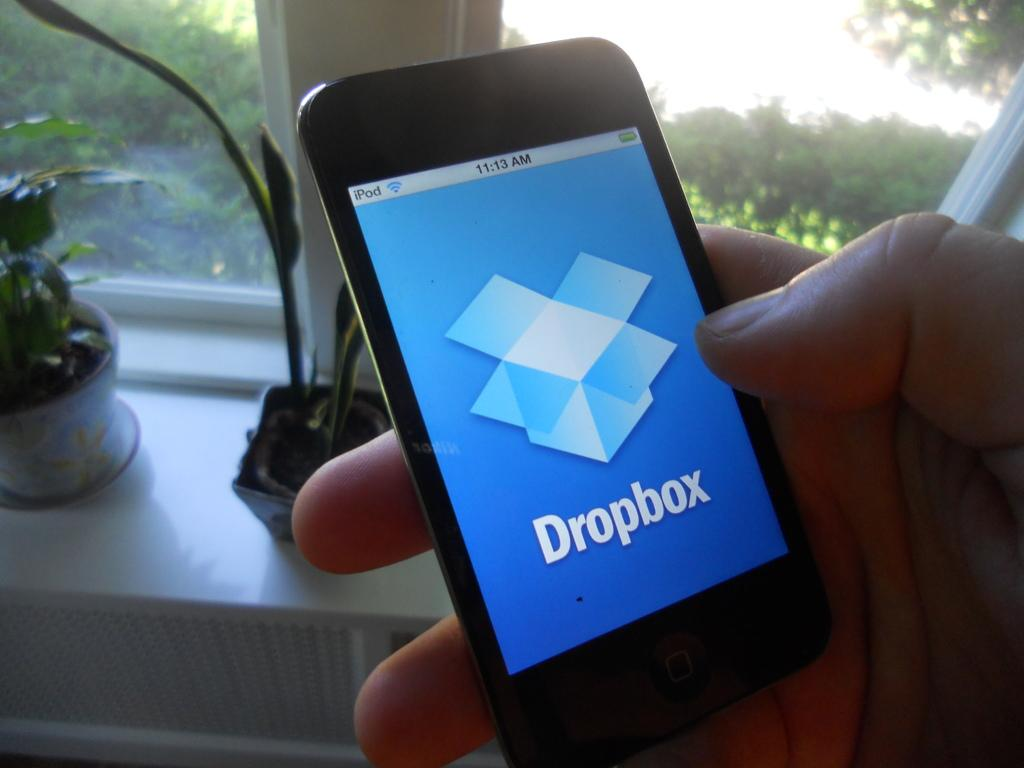What is the person in the image holding? The person is holding a mobile in the image. What part of the person is visible in the image? Only the person's hand is visible in the image. What can be seen behind the mobile? There are house plants behind the mobile. What architectural feature is present in the image? There is a glass window in the image. What type of unit can be seen in the image? There is no unit present in the image. Are there any railway tracks visible in the image? There are no railway tracks present in the image. 